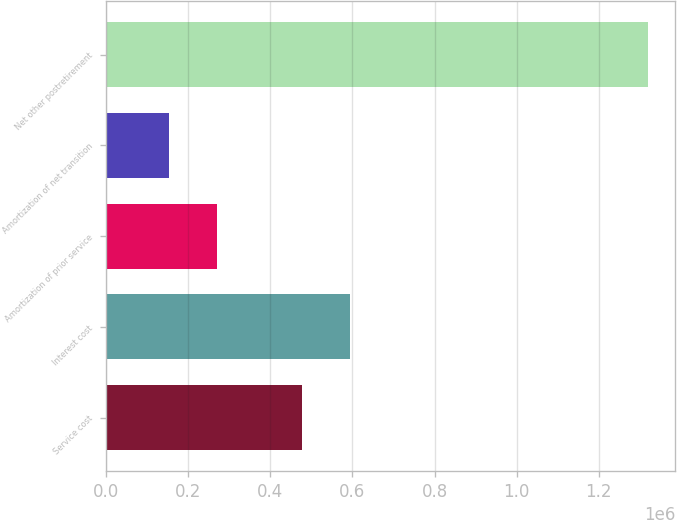<chart> <loc_0><loc_0><loc_500><loc_500><bar_chart><fcel>Service cost<fcel>Interest cost<fcel>Amortization of prior service<fcel>Amortization of net transition<fcel>Net other postretirement<nl><fcel>477000<fcel>593700<fcel>270700<fcel>154000<fcel>1.321e+06<nl></chart> 